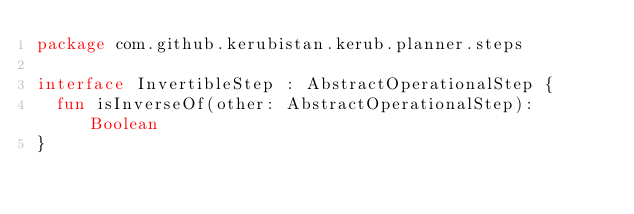<code> <loc_0><loc_0><loc_500><loc_500><_Kotlin_>package com.github.kerubistan.kerub.planner.steps

interface InvertibleStep : AbstractOperationalStep {
	fun isInverseOf(other: AbstractOperationalStep): Boolean
}</code> 